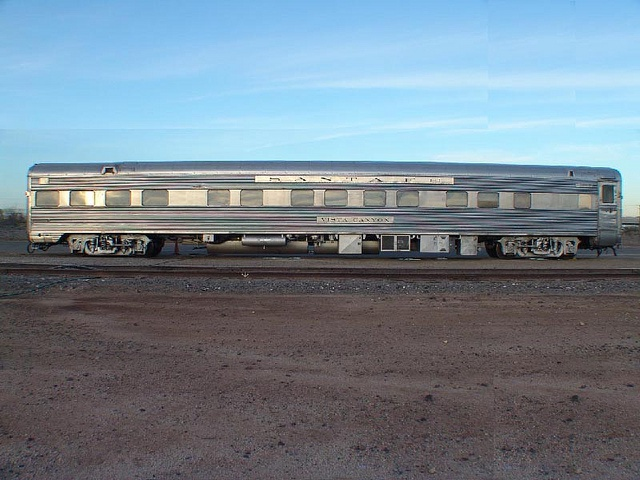Describe the objects in this image and their specific colors. I can see a train in darkgray, gray, and black tones in this image. 